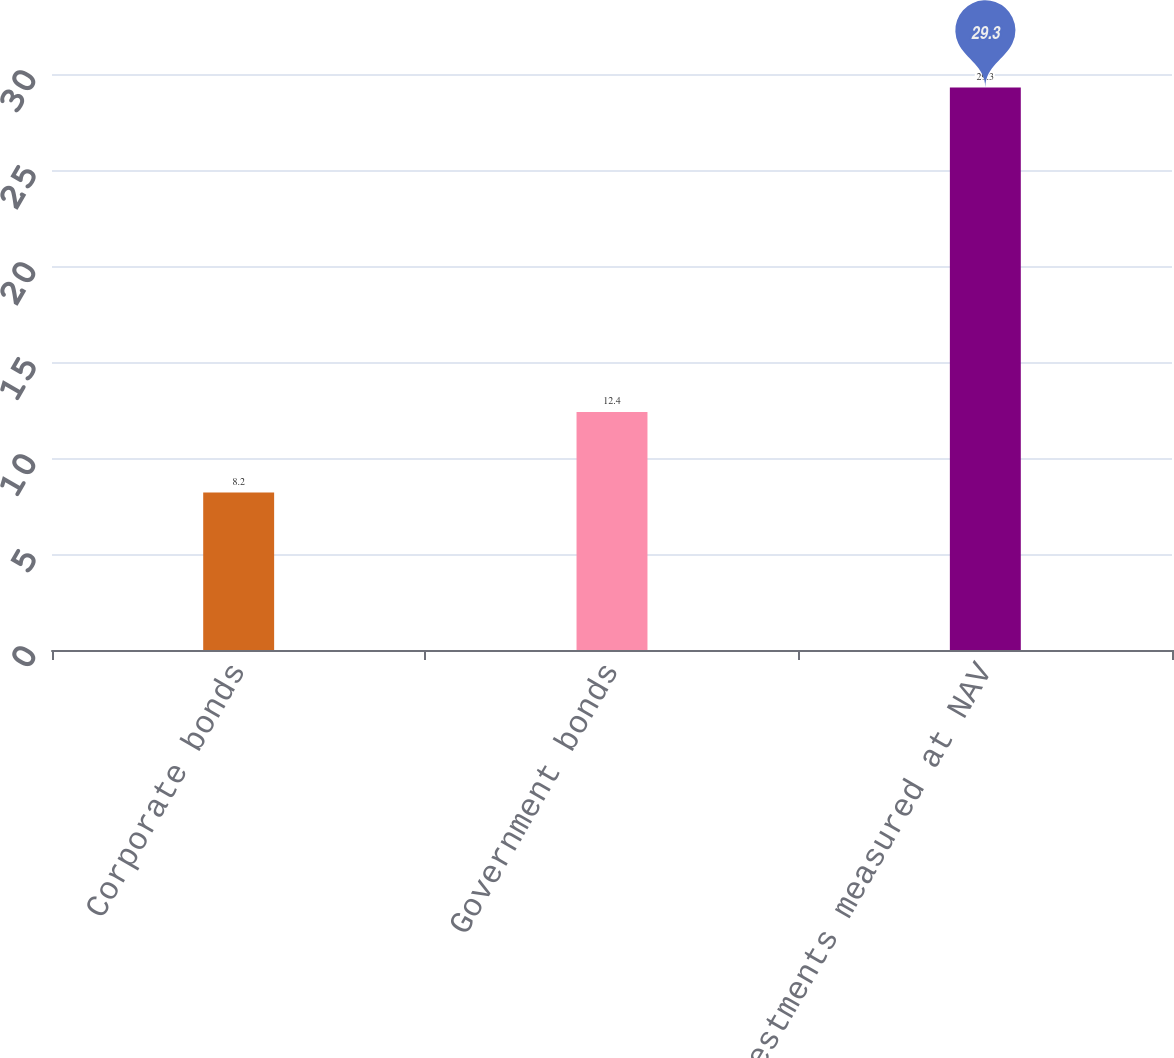Convert chart to OTSL. <chart><loc_0><loc_0><loc_500><loc_500><bar_chart><fcel>Corporate bonds<fcel>Government bonds<fcel>Investments measured at NAV<nl><fcel>8.2<fcel>12.4<fcel>29.3<nl></chart> 